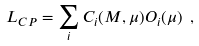Convert formula to latex. <formula><loc_0><loc_0><loc_500><loc_500>L _ { C P } = \sum _ { i } C _ { i } ( M , \mu ) O _ { i } ( \mu ) \ ,</formula> 